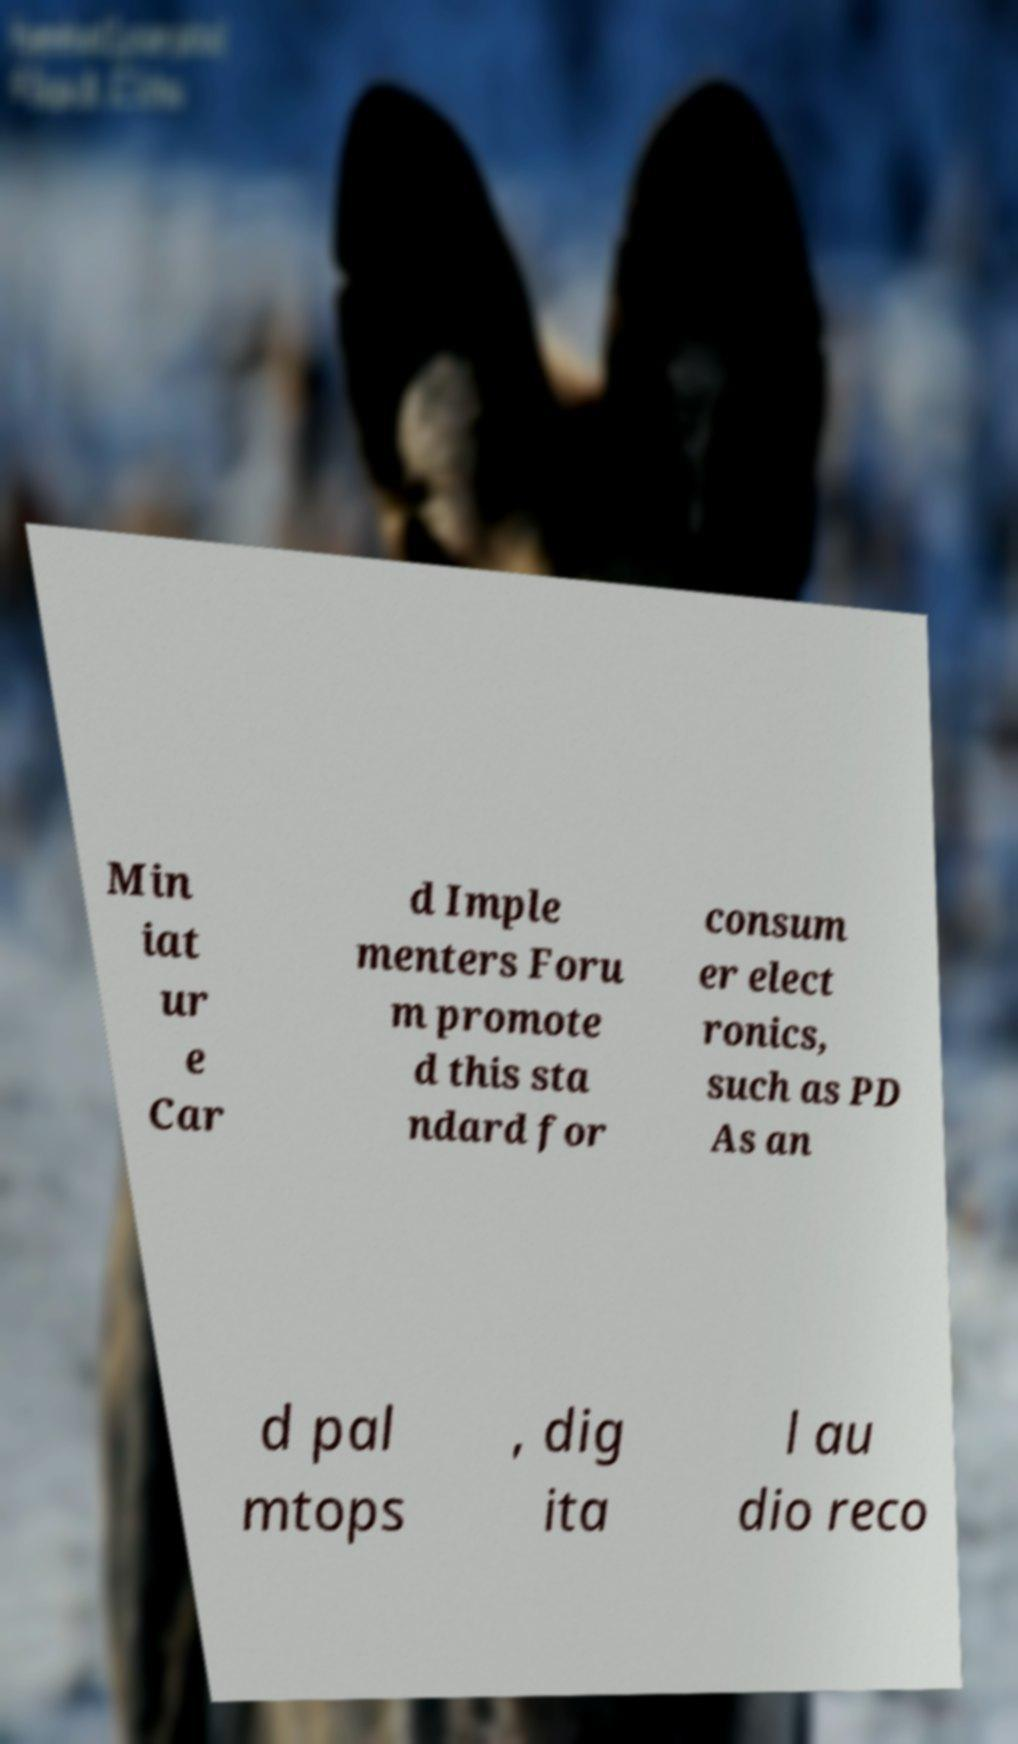Can you accurately transcribe the text from the provided image for me? Min iat ur e Car d Imple menters Foru m promote d this sta ndard for consum er elect ronics, such as PD As an d pal mtops , dig ita l au dio reco 